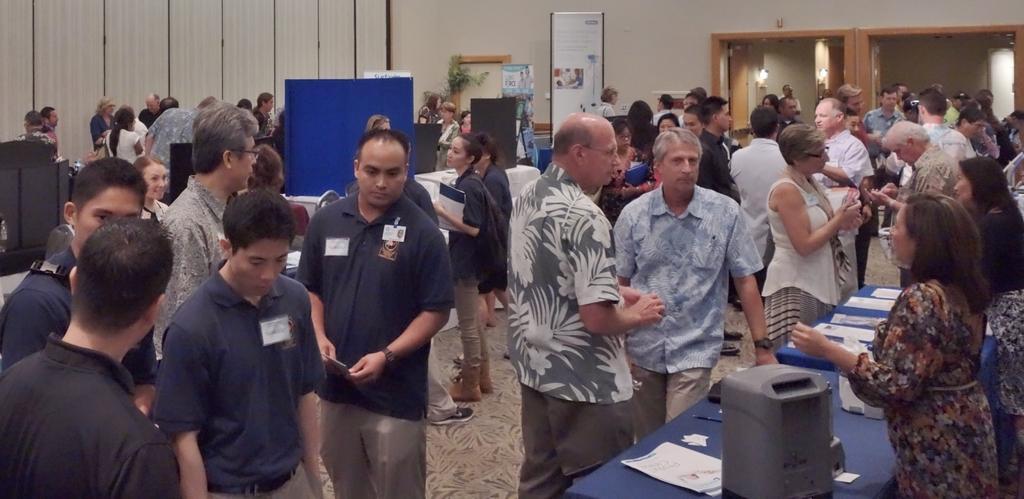Describe this image in one or two sentences. In this picture, we see the people are standing. On the right side, we see a table on which a grey color object and the papers are placed. Beside that, we see the people are standing and they are trying to talk something. On the left side, we see the people are standing and we see the boards in black and blue color. Beside that, we see the boards in white and blue color with some text written on it. Beside that, we see the people are standing. In the background, we see a door and a wall. We even see the lights. 